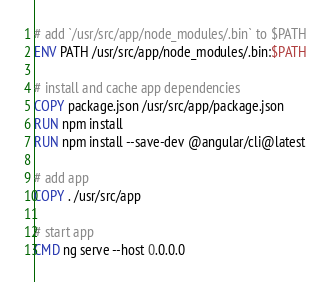<code> <loc_0><loc_0><loc_500><loc_500><_Dockerfile_># add `/usr/src/app/node_modules/.bin` to $PATH
ENV PATH /usr/src/app/node_modules/.bin:$PATH

# install and cache app dependencies
COPY package.json /usr/src/app/package.json
RUN npm install
RUN npm install --save-dev @angular/cli@latest

# add app
COPY . /usr/src/app

# start app
CMD ng serve --host 0.0.0.0</code> 